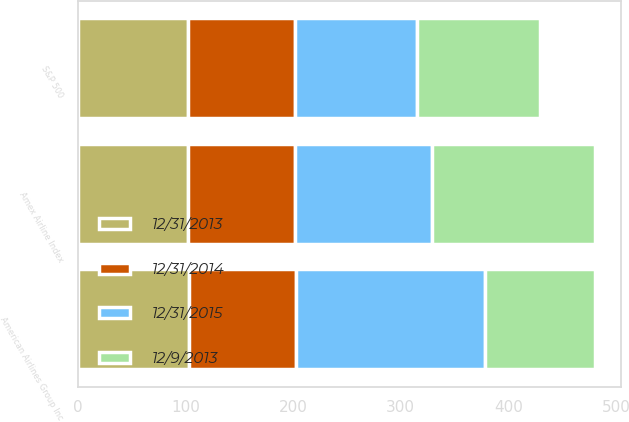<chart> <loc_0><loc_0><loc_500><loc_500><stacked_bar_chart><ecel><fcel>American Airlines Group Inc<fcel>Amex Airline Index<fcel>S&P 500<nl><fcel>12/31/2014<fcel>100<fcel>100<fcel>100<nl><fcel>12/31/2013<fcel>103<fcel>102<fcel>102<nl><fcel>12/9/2013<fcel>103<fcel>152<fcel>114<nl><fcel>12/31/2015<fcel>175<fcel>127<fcel>113<nl></chart> 